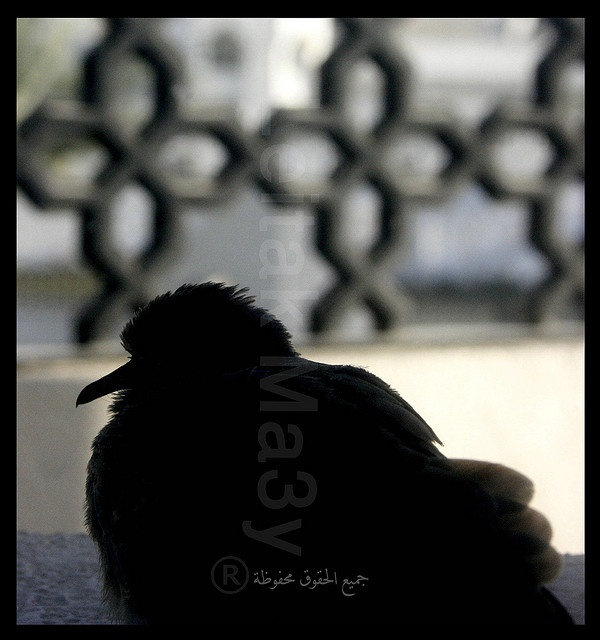Describe the objects in this image and their specific colors. I can see a bird in black and gray tones in this image. 